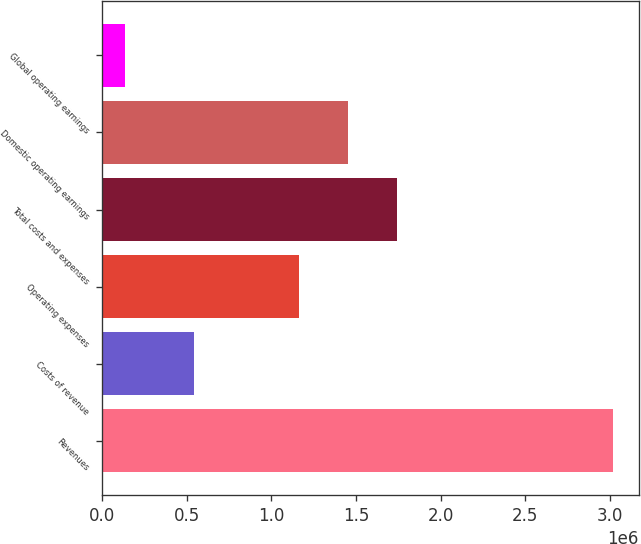Convert chart to OTSL. <chart><loc_0><loc_0><loc_500><loc_500><bar_chart><fcel>Revenues<fcel>Costs of revenue<fcel>Operating expenses<fcel>Total costs and expenses<fcel>Domestic operating earnings<fcel>Global operating earnings<nl><fcel>3.02179e+06<fcel>542210<fcel>1.16341e+06<fcel>1.74061e+06<fcel>1.45201e+06<fcel>135781<nl></chart> 